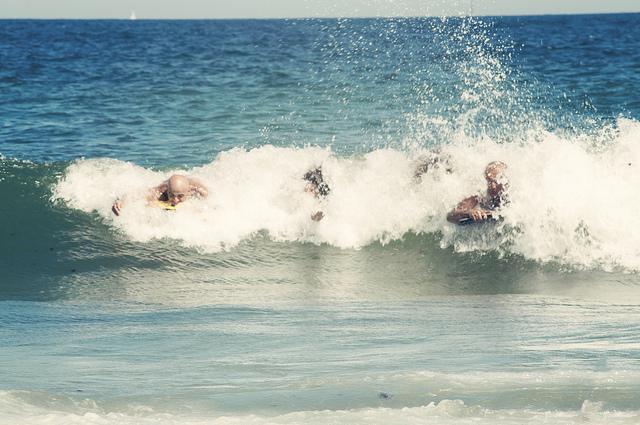How many humans in this scene?
Give a very brief answer. 3. 